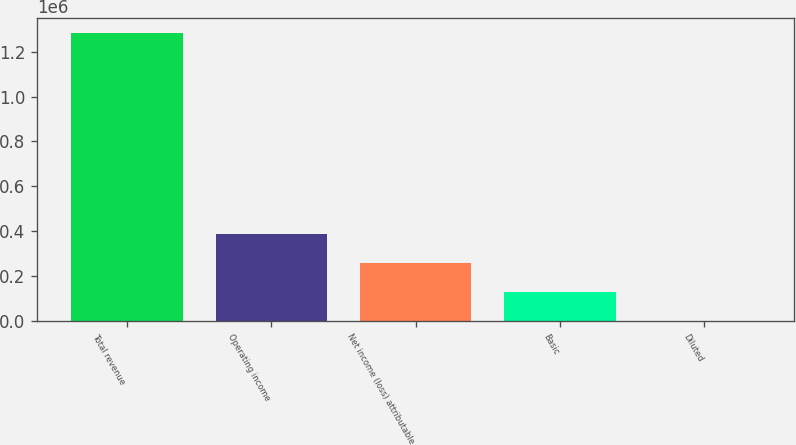Convert chart to OTSL. <chart><loc_0><loc_0><loc_500><loc_500><bar_chart><fcel>Total revenue<fcel>Operating income<fcel>Net income (loss) attributable<fcel>Basic<fcel>Diluted<nl><fcel>1.28491e+06<fcel>385474<fcel>256983<fcel>128492<fcel>1.09<nl></chart> 